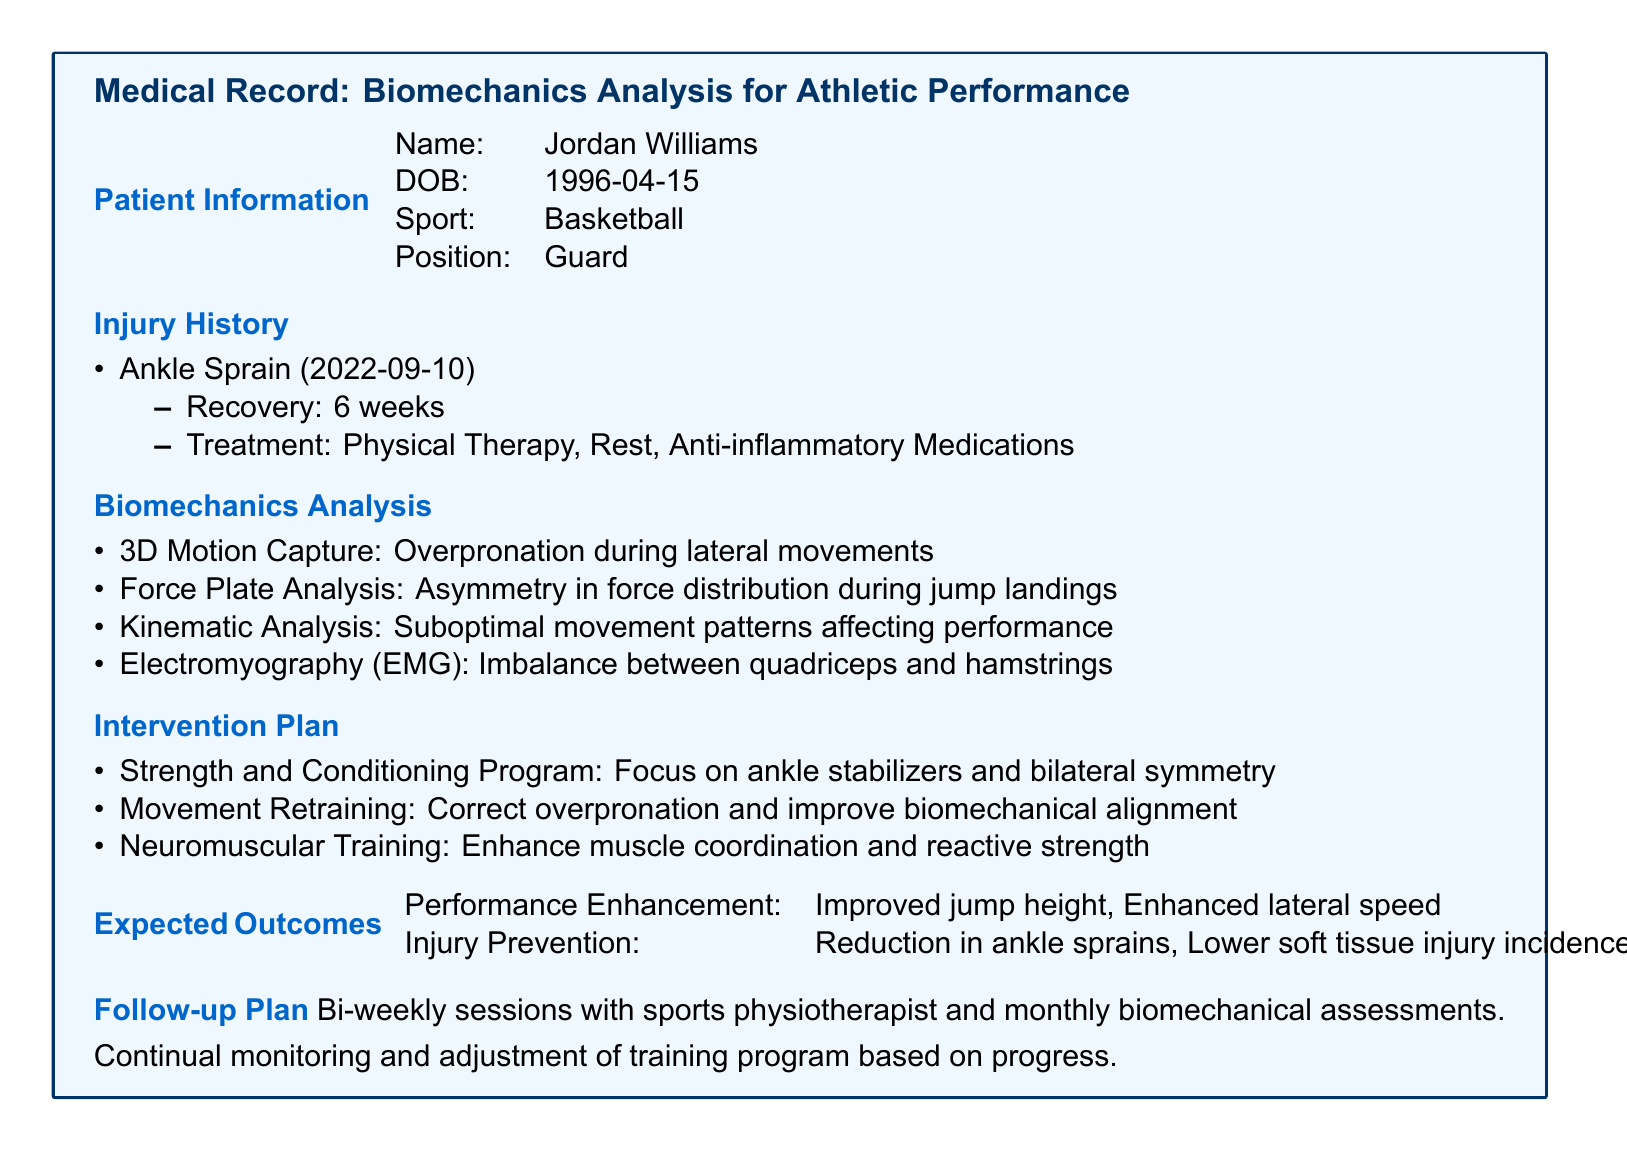What is the name of the patient? The patient's name is provided in the patient information section of the document.
Answer: Jordan Williams What is the patient's date of birth? The date of birth is explicitly stated in the patient information section.
Answer: 1996-04-15 What sport does the patient play? The patient's sport is mentioned in the document under patient information.
Answer: Basketball What type of injury did the patient have? The injury history section lists the specific type of injury the patient suffered from.
Answer: Ankle Sprain How long was the recovery period for the injury? The recovery time is detailed in the injury history section.
Answer: 6 weeks What intervention focuses on correcting overpronation? The biomechanical intervention plan outlines specific focus areas, including this one.
Answer: Movement Retraining What does the EMG analysis indicate? The electromyography section describes the imbalance identified in the patient's muscle groups.
Answer: Imbalance between quadriceps and hamstrings What is one expected performance enhancement? The expected outcomes section mentions specific performance enhancements anticipated from the intervention plan.
Answer: Improved jump height How often will follow-up sessions occur? The follow-up plan specifies the frequency of follow-up sessions with the sports physiotherapist.
Answer: Bi-weekly What is the aim of the strength and conditioning program? The intervention plan outlines the specific aims of the program designed for the patient.
Answer: Focus on ankle stabilizers and bilateral symmetry 